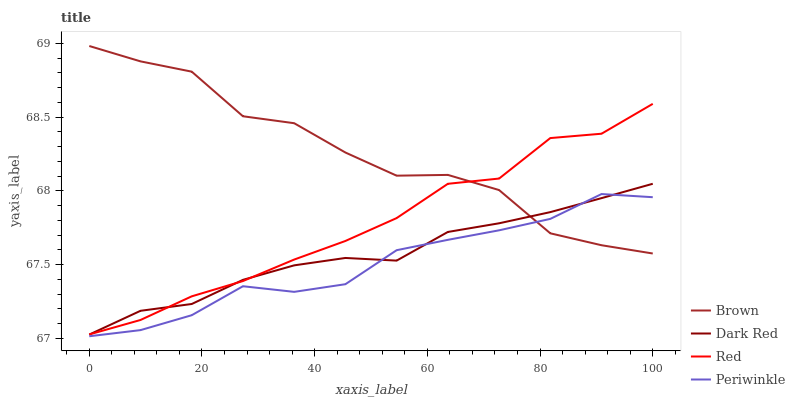Does Red have the minimum area under the curve?
Answer yes or no. No. Does Red have the maximum area under the curve?
Answer yes or no. No. Is Periwinkle the smoothest?
Answer yes or no. No. Is Periwinkle the roughest?
Answer yes or no. No. Does Red have the lowest value?
Answer yes or no. No. Does Red have the highest value?
Answer yes or no. No. Is Periwinkle less than Red?
Answer yes or no. Yes. Is Red greater than Periwinkle?
Answer yes or no. Yes. Does Periwinkle intersect Red?
Answer yes or no. No. 